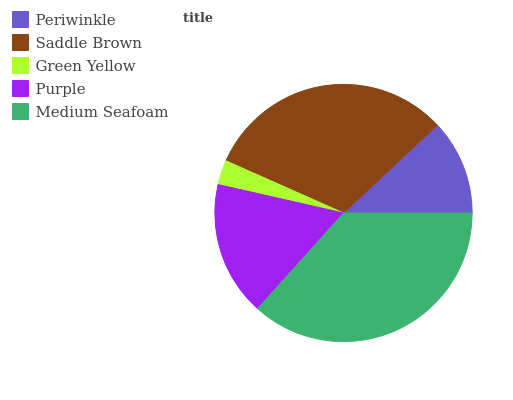Is Green Yellow the minimum?
Answer yes or no. Yes. Is Medium Seafoam the maximum?
Answer yes or no. Yes. Is Saddle Brown the minimum?
Answer yes or no. No. Is Saddle Brown the maximum?
Answer yes or no. No. Is Saddle Brown greater than Periwinkle?
Answer yes or no. Yes. Is Periwinkle less than Saddle Brown?
Answer yes or no. Yes. Is Periwinkle greater than Saddle Brown?
Answer yes or no. No. Is Saddle Brown less than Periwinkle?
Answer yes or no. No. Is Purple the high median?
Answer yes or no. Yes. Is Purple the low median?
Answer yes or no. Yes. Is Periwinkle the high median?
Answer yes or no. No. Is Medium Seafoam the low median?
Answer yes or no. No. 